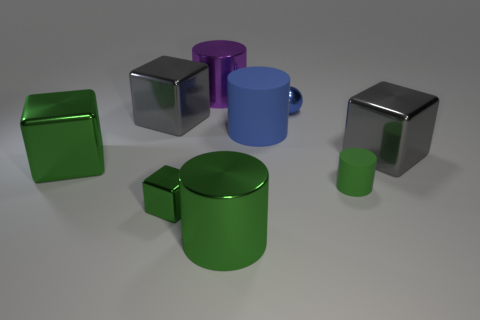Add 1 large blue rubber objects. How many objects exist? 10 Subtract all purple metallic cylinders. How many cylinders are left? 3 Subtract all purple cylinders. How many cylinders are left? 3 Subtract 0 cyan cylinders. How many objects are left? 9 Subtract all blocks. How many objects are left? 5 Subtract all gray blocks. Subtract all blue cylinders. How many blocks are left? 2 Subtract all red cylinders. How many red blocks are left? 0 Subtract all small cubes. Subtract all gray metal objects. How many objects are left? 6 Add 2 big green cylinders. How many big green cylinders are left? 3 Add 4 purple things. How many purple things exist? 5 